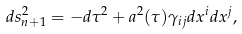Convert formula to latex. <formula><loc_0><loc_0><loc_500><loc_500>d s _ { n + 1 } ^ { 2 } = - d \tau ^ { 2 } + a ^ { 2 } ( \tau ) \gamma _ { i j } d x ^ { i } d x ^ { j } ,</formula> 